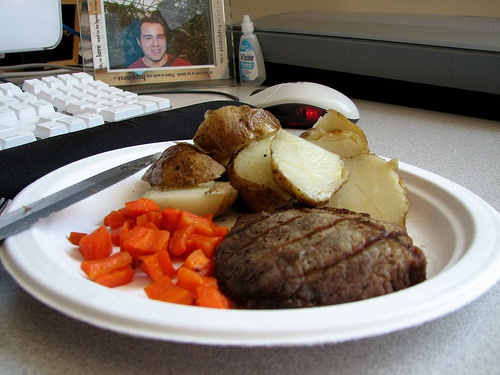Describe the objects in this image and their specific colors. I can see carrot in lavender, red, and brown tones, keyboard in lavender, lightgray, darkgray, lightblue, and black tones, mouse in lavender, black, darkgray, lightgray, and maroon tones, knife in lavender, gray, and darkgray tones, and tv in lavender, lightgray, darkgray, and teal tones in this image. 